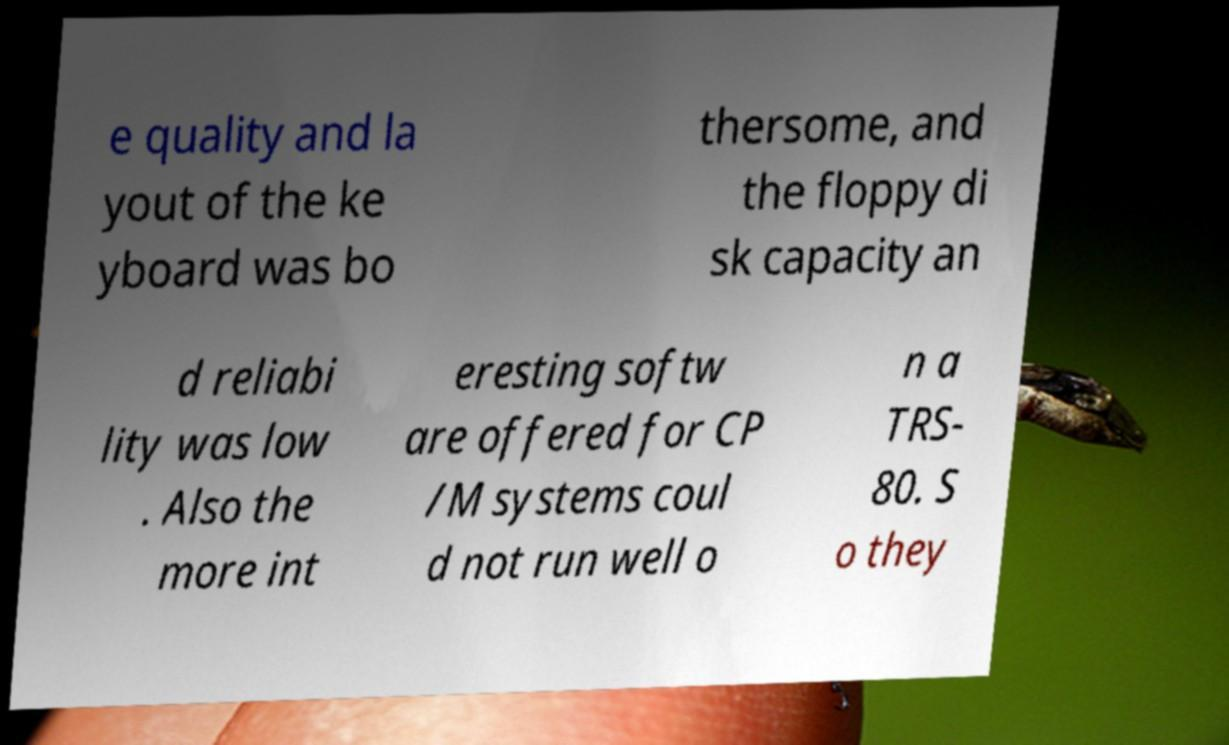What messages or text are displayed in this image? I need them in a readable, typed format. e quality and la yout of the ke yboard was bo thersome, and the floppy di sk capacity an d reliabi lity was low . Also the more int eresting softw are offered for CP /M systems coul d not run well o n a TRS- 80. S o they 